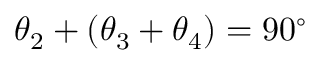Convert formula to latex. <formula><loc_0><loc_0><loc_500><loc_500>\theta _ { 2 } + ( \theta _ { 3 } + \theta _ { 4 } ) = 9 0 ^ { \circ }</formula> 